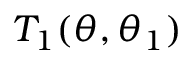Convert formula to latex. <formula><loc_0><loc_0><loc_500><loc_500>T _ { 1 } ( \theta , \theta _ { 1 } )</formula> 